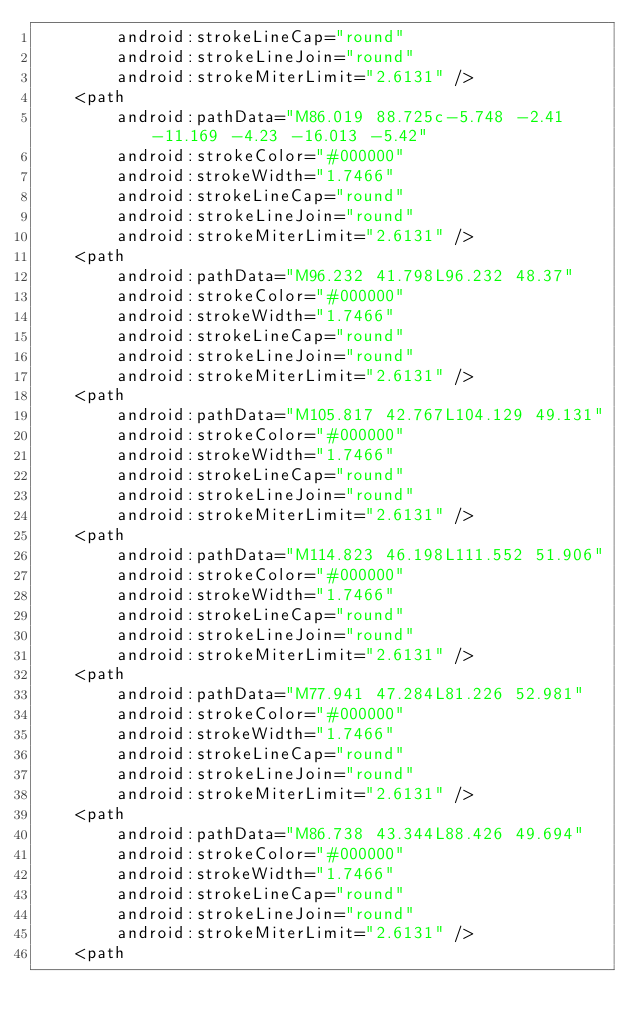<code> <loc_0><loc_0><loc_500><loc_500><_XML_>        android:strokeLineCap="round"
        android:strokeLineJoin="round"
        android:strokeMiterLimit="2.6131" />
    <path
        android:pathData="M86.019 88.725c-5.748 -2.41 -11.169 -4.23 -16.013 -5.42"
        android:strokeColor="#000000"
        android:strokeWidth="1.7466"
        android:strokeLineCap="round"
        android:strokeLineJoin="round"
        android:strokeMiterLimit="2.6131" />
    <path
        android:pathData="M96.232 41.798L96.232 48.37"
        android:strokeColor="#000000"
        android:strokeWidth="1.7466"
        android:strokeLineCap="round"
        android:strokeLineJoin="round"
        android:strokeMiterLimit="2.6131" />
    <path
        android:pathData="M105.817 42.767L104.129 49.131"
        android:strokeColor="#000000"
        android:strokeWidth="1.7466"
        android:strokeLineCap="round"
        android:strokeLineJoin="round"
        android:strokeMiterLimit="2.6131" />
    <path
        android:pathData="M114.823 46.198L111.552 51.906"
        android:strokeColor="#000000"
        android:strokeWidth="1.7466"
        android:strokeLineCap="round"
        android:strokeLineJoin="round"
        android:strokeMiterLimit="2.6131" />
    <path
        android:pathData="M77.941 47.284L81.226 52.981"
        android:strokeColor="#000000"
        android:strokeWidth="1.7466"
        android:strokeLineCap="round"
        android:strokeLineJoin="round"
        android:strokeMiterLimit="2.6131" />
    <path
        android:pathData="M86.738 43.344L88.426 49.694"
        android:strokeColor="#000000"
        android:strokeWidth="1.7466"
        android:strokeLineCap="round"
        android:strokeLineJoin="round"
        android:strokeMiterLimit="2.6131" />
    <path</code> 